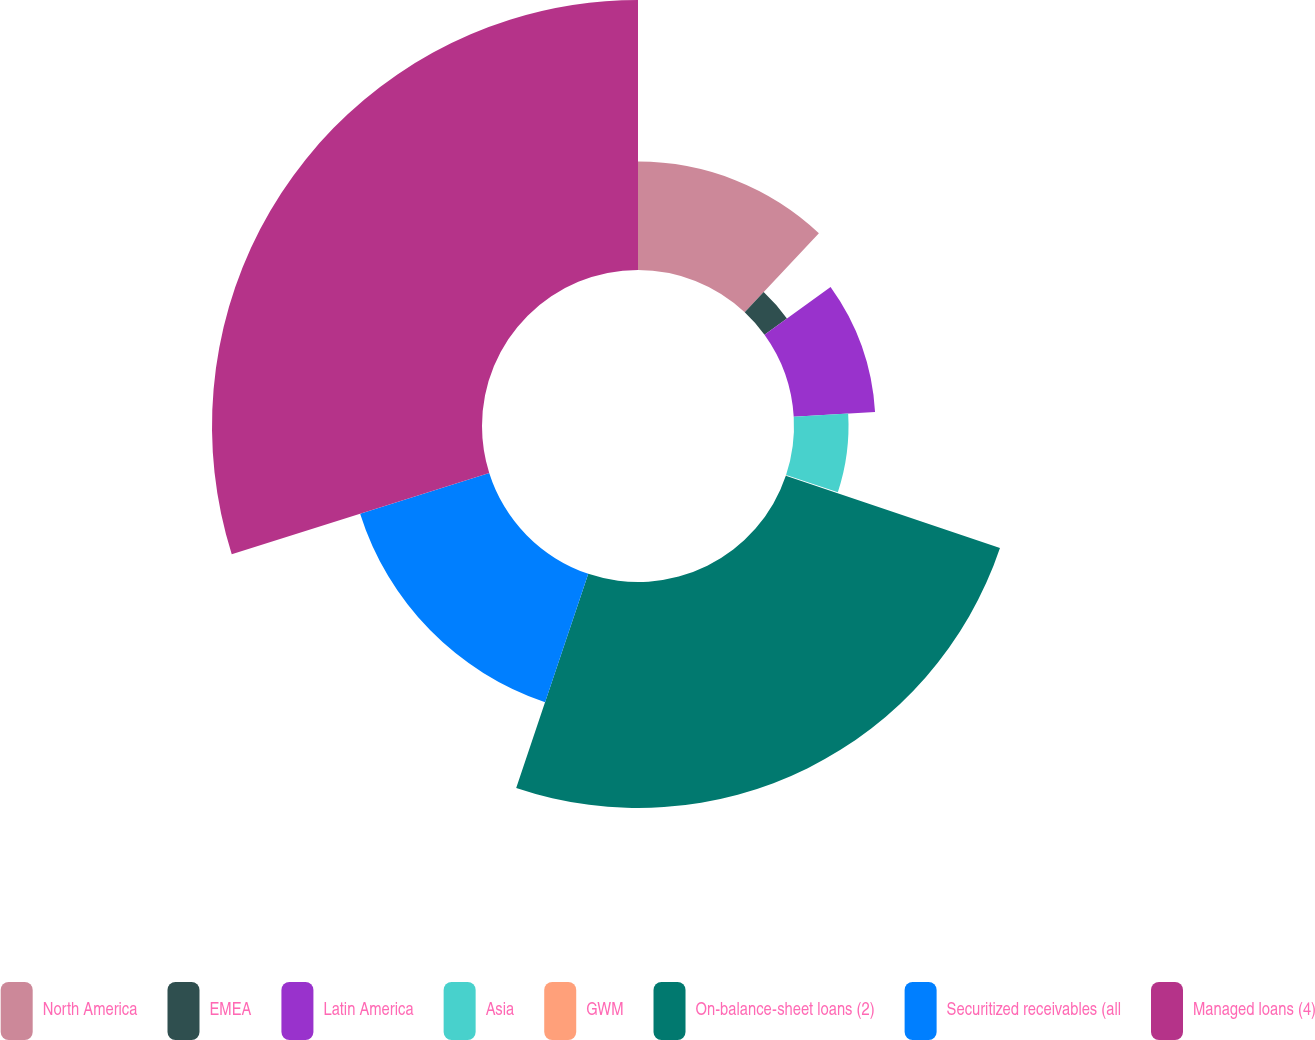Convert chart. <chart><loc_0><loc_0><loc_500><loc_500><pie_chart><fcel>North America<fcel>EMEA<fcel>Latin America<fcel>Asia<fcel>GWM<fcel>On-balance-sheet loans (2)<fcel>Securitized receivables (all<fcel>Managed loans (4)<nl><fcel>11.99%<fcel>3.06%<fcel>9.01%<fcel>6.03%<fcel>0.08%<fcel>24.99%<fcel>14.97%<fcel>29.86%<nl></chart> 